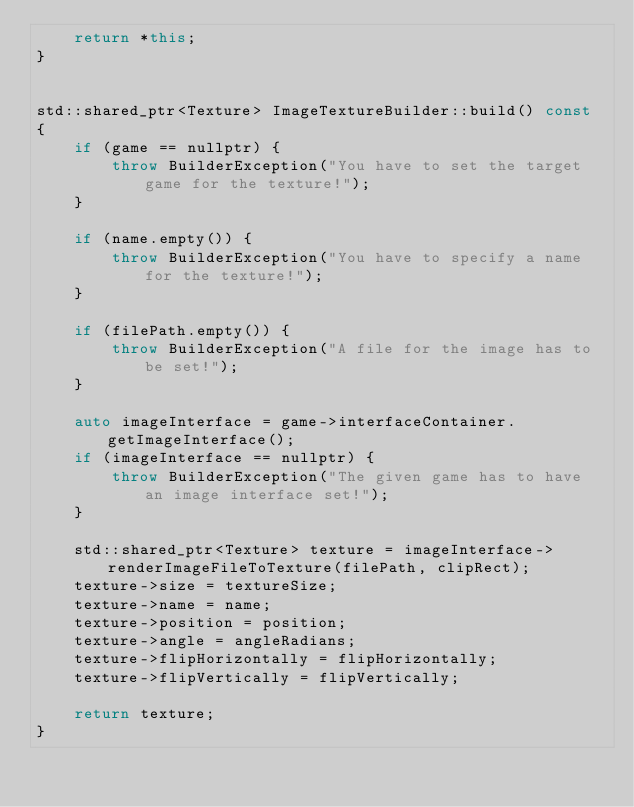<code> <loc_0><loc_0><loc_500><loc_500><_C++_>    return *this;
}


std::shared_ptr<Texture> ImageTextureBuilder::build() const
{
    if (game == nullptr) {
        throw BuilderException("You have to set the target game for the texture!");
    }

    if (name.empty()) {
        throw BuilderException("You have to specify a name for the texture!");
    }

    if (filePath.empty()) {
        throw BuilderException("A file for the image has to be set!");
    }

    auto imageInterface = game->interfaceContainer.getImageInterface();
    if (imageInterface == nullptr) {
        throw BuilderException("The given game has to have an image interface set!");
    }

    std::shared_ptr<Texture> texture = imageInterface->renderImageFileToTexture(filePath, clipRect);
    texture->size = textureSize;
    texture->name = name;
    texture->position = position;
    texture->angle = angleRadians;
    texture->flipHorizontally = flipHorizontally;
    texture->flipVertically = flipVertically;
    
    return texture;
}</code> 